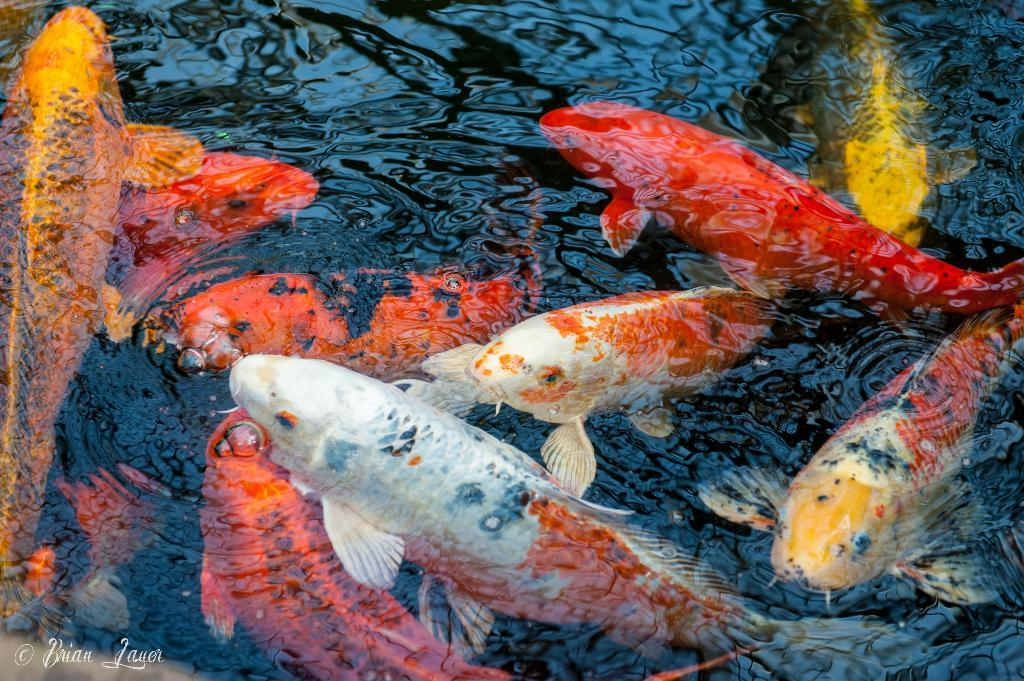What type of animals can be seen in the image? There are fishes in the water in the image. Is there any text or marking visible in the image? Yes, there is a watermark in the bottom left corner of the image. How many rabbits can be seen playing in the sand in the image? There are no rabbits or sand present in the image; it features fishes in the water and a watermark in the bottom left corner. 